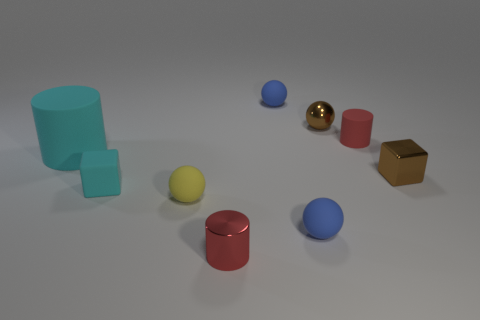Subtract all cylinders. How many objects are left? 6 Subtract all small cyan things. Subtract all brown metallic balls. How many objects are left? 7 Add 7 cyan things. How many cyan things are left? 9 Add 8 big blue metal things. How many big blue metal things exist? 8 Subtract 1 cyan cylinders. How many objects are left? 8 